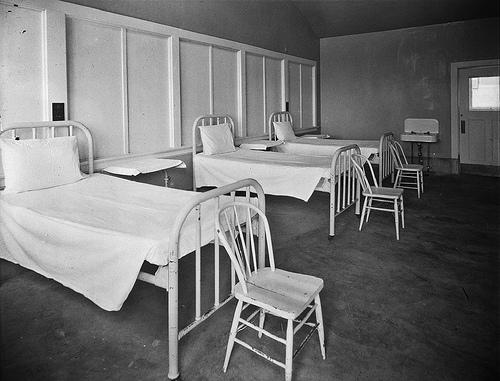Why are the beds empty?
Short answer required. No patients. Is this a little girls bedroom?
Concise answer only. No. Is there anyone in these beds?
Be succinct. No. 